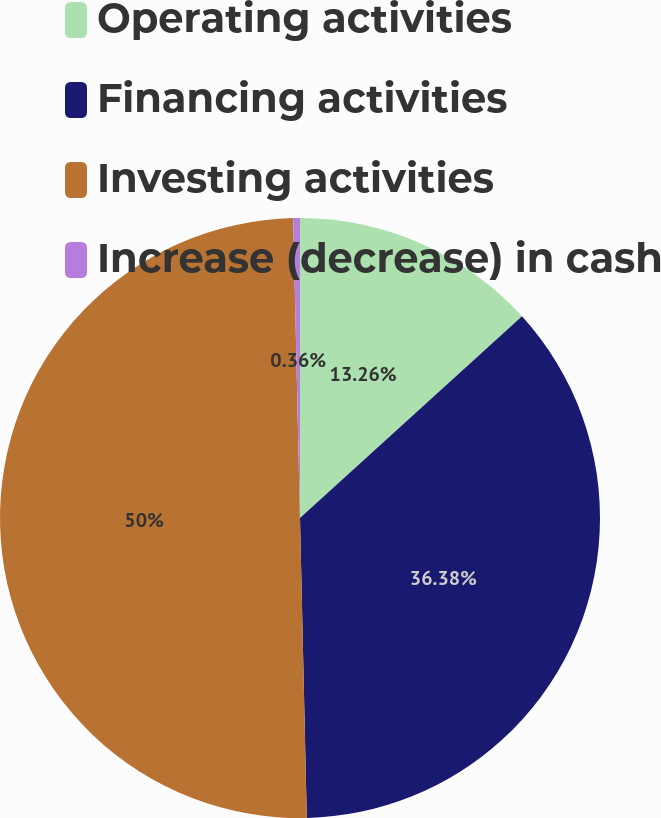Convert chart. <chart><loc_0><loc_0><loc_500><loc_500><pie_chart><fcel>Operating activities<fcel>Financing activities<fcel>Investing activities<fcel>Increase (decrease) in cash<nl><fcel>13.26%<fcel>36.38%<fcel>50.0%<fcel>0.36%<nl></chart> 